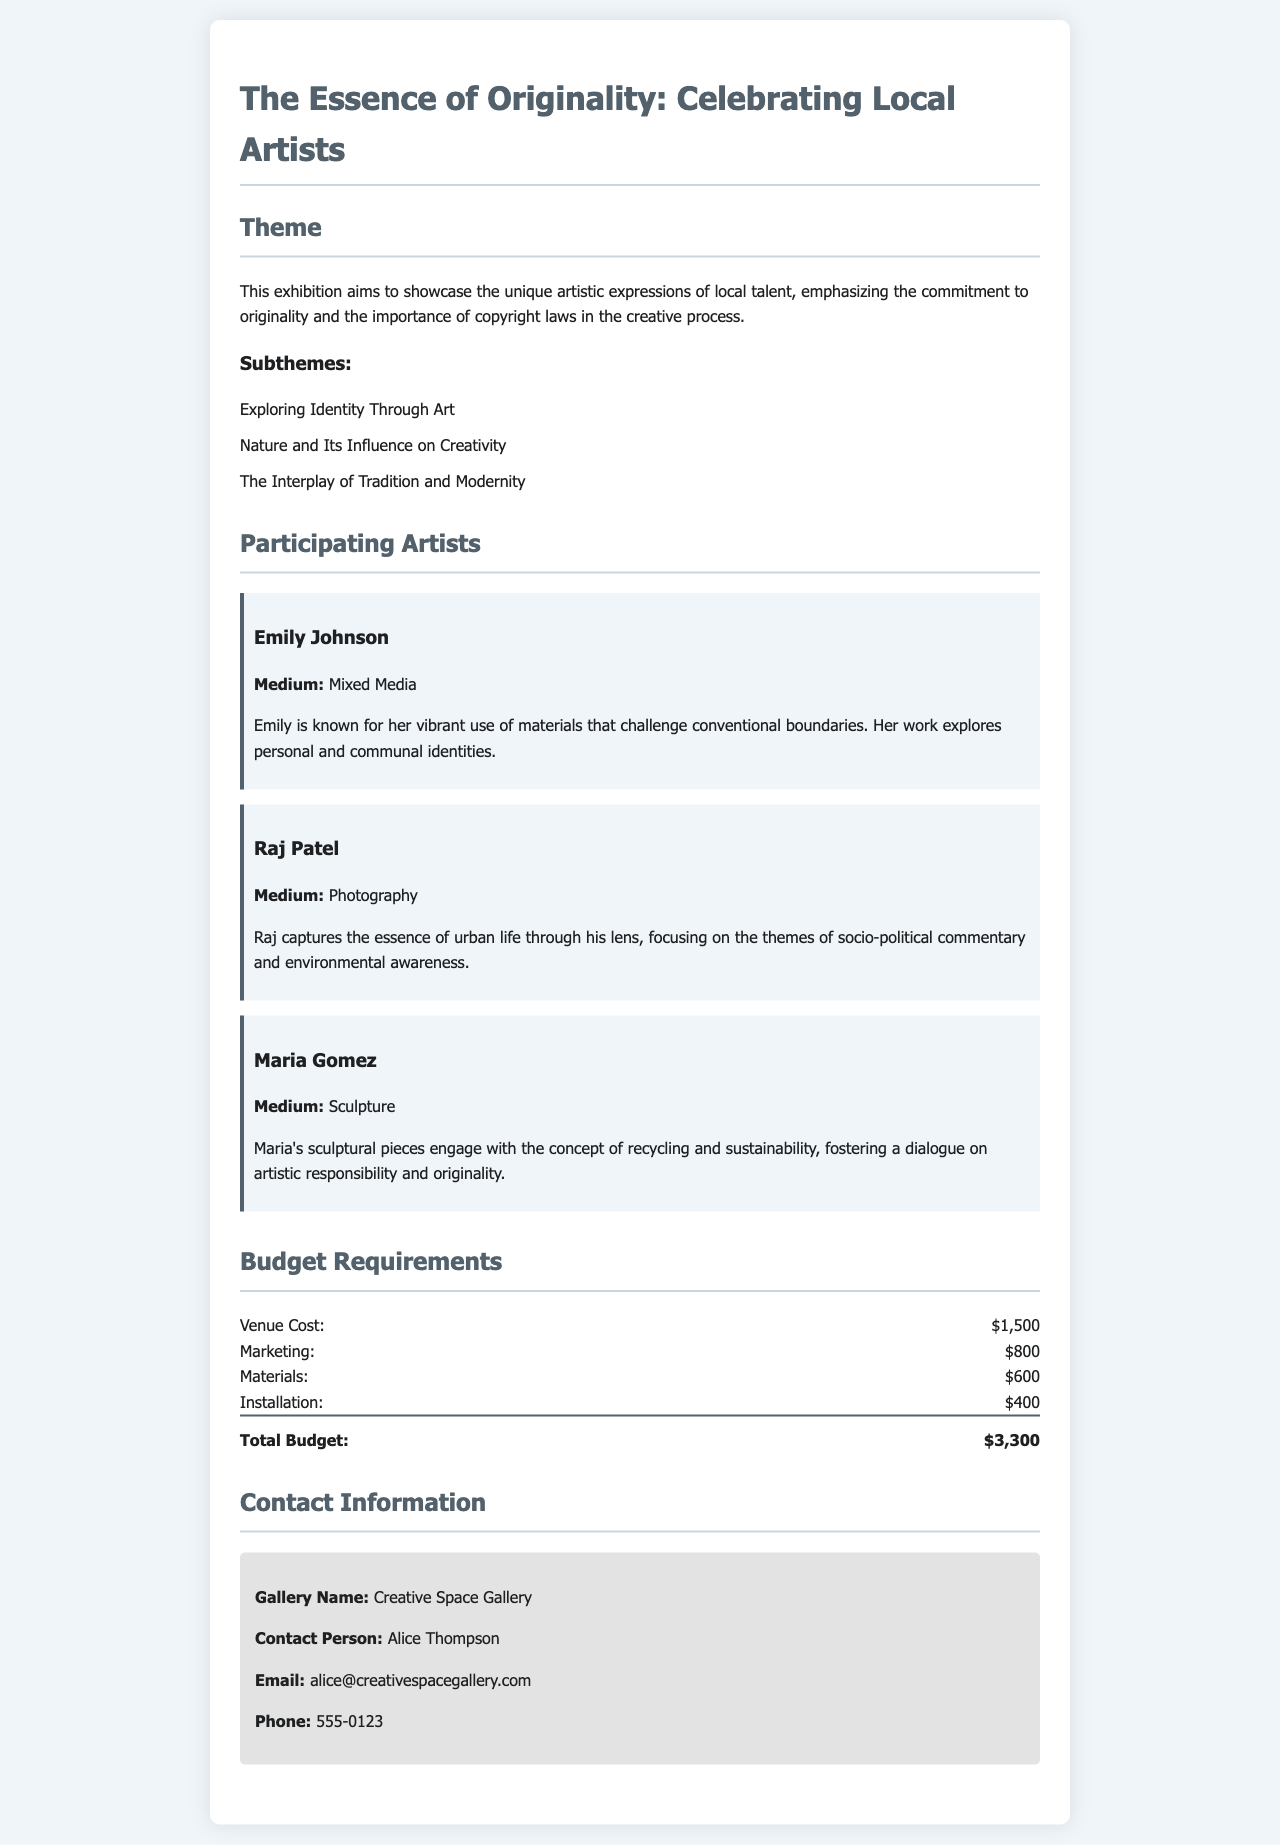What is the theme of the exhibition? The theme is described as the main focus of the exhibition, which highlights the commitment to originality and copyright laws.
Answer: The Essence of Originality: Celebrating Local Artists Who are the participating artists? The document lists the names of the artists involved in the exhibition.
Answer: Emily Johnson, Raj Patel, Maria Gomez What is the medium used by Emily Johnson? The document specifies the type of artistic medium that Emily Johnson works with.
Answer: Mixed Media What is the total budget for the exhibition? The total budget is calculated by summing up the individual budget items listed in the document.
Answer: $3,300 What subtheme relates to personal expression in art? The subtheme focuses on identity and how it is expressed through artistic work, which is noted in the document.
Answer: Exploring Identity Through Art How much is allocated for marketing? This question asks for a specific budget line item mentioned in the document.
Answer: $800 What kind of sculptures does Maria Gomez create? This question refers to the thematic focus of Maria Gomez's artwork as described in the document.
Answer: Recycling and sustainability Who is the contact person for the gallery? The contact person is identified as the main point of communication for the exhibition proposal.
Answer: Alice Thompson 